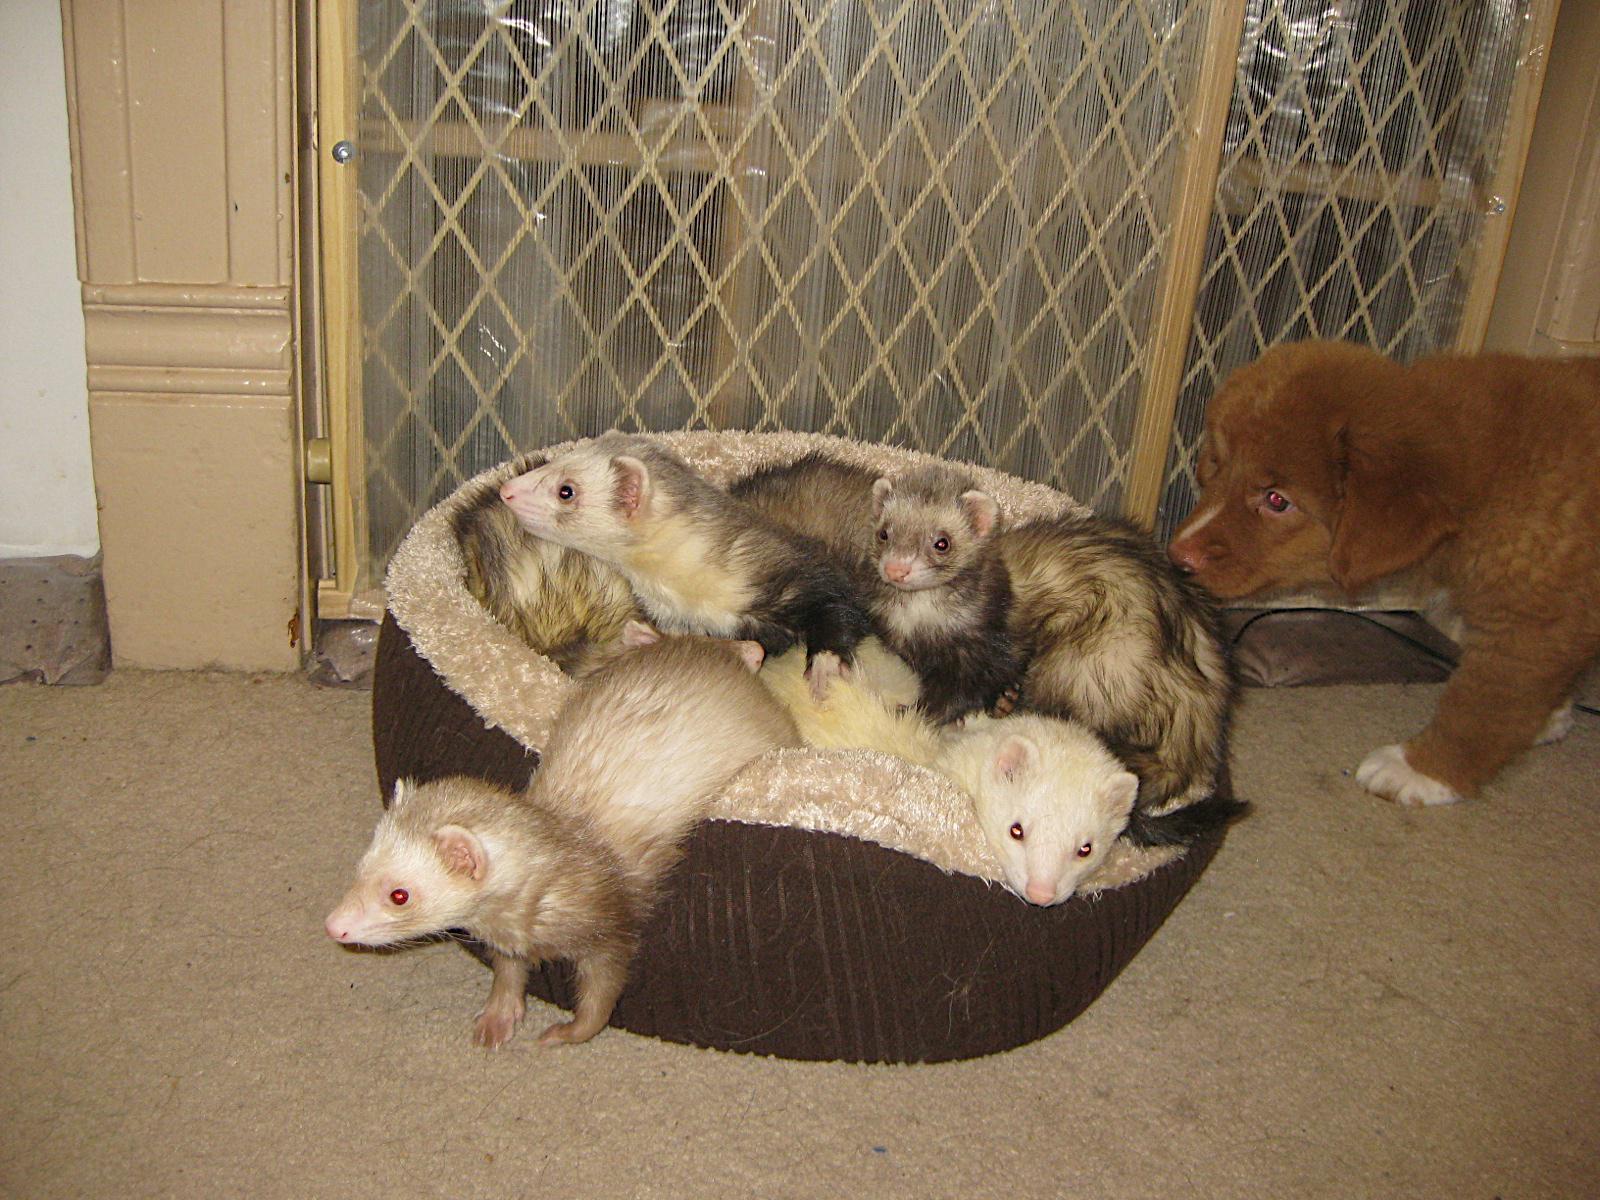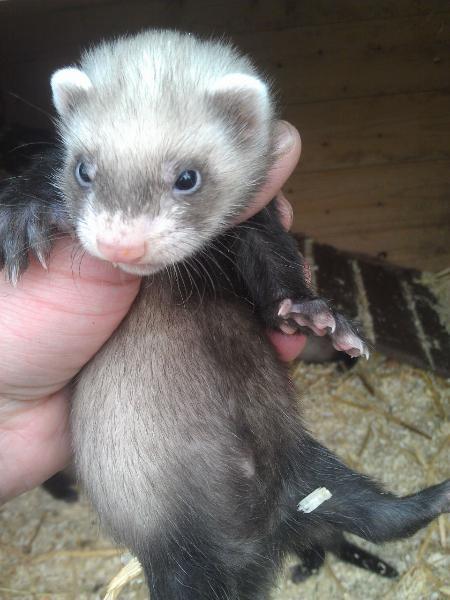The first image is the image on the left, the second image is the image on the right. Evaluate the accuracy of this statement regarding the images: "At least four ferrets are in the same container in one image.". Is it true? Answer yes or no. Yes. The first image is the image on the left, the second image is the image on the right. Assess this claim about the two images: "At least one baby ferret is being held by a human hand.". Correct or not? Answer yes or no. Yes. 